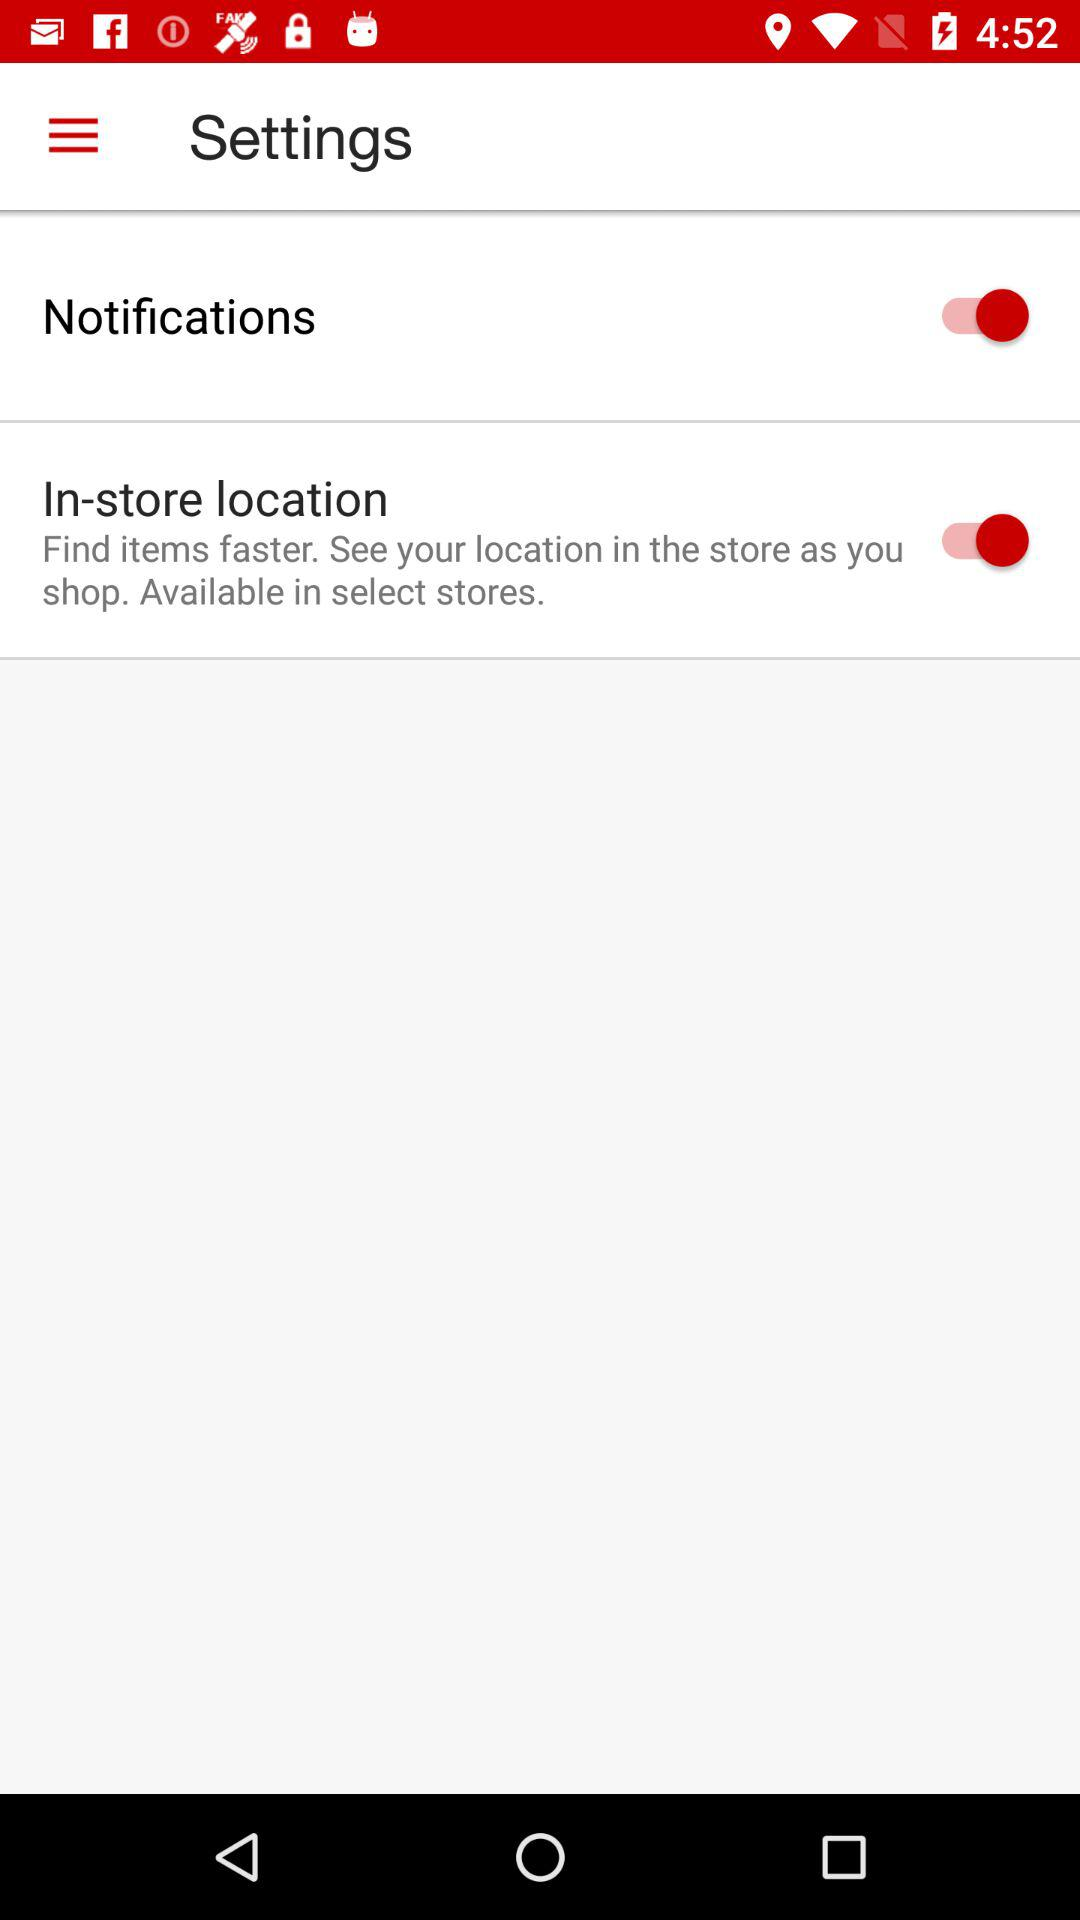What is the status of notifications? The status is on. 